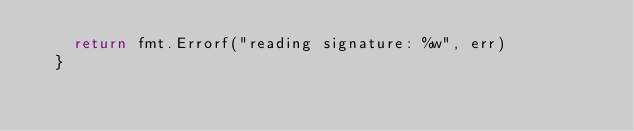<code> <loc_0><loc_0><loc_500><loc_500><_Go_>		return fmt.Errorf("reading signature: %w", err)
	}
</code> 